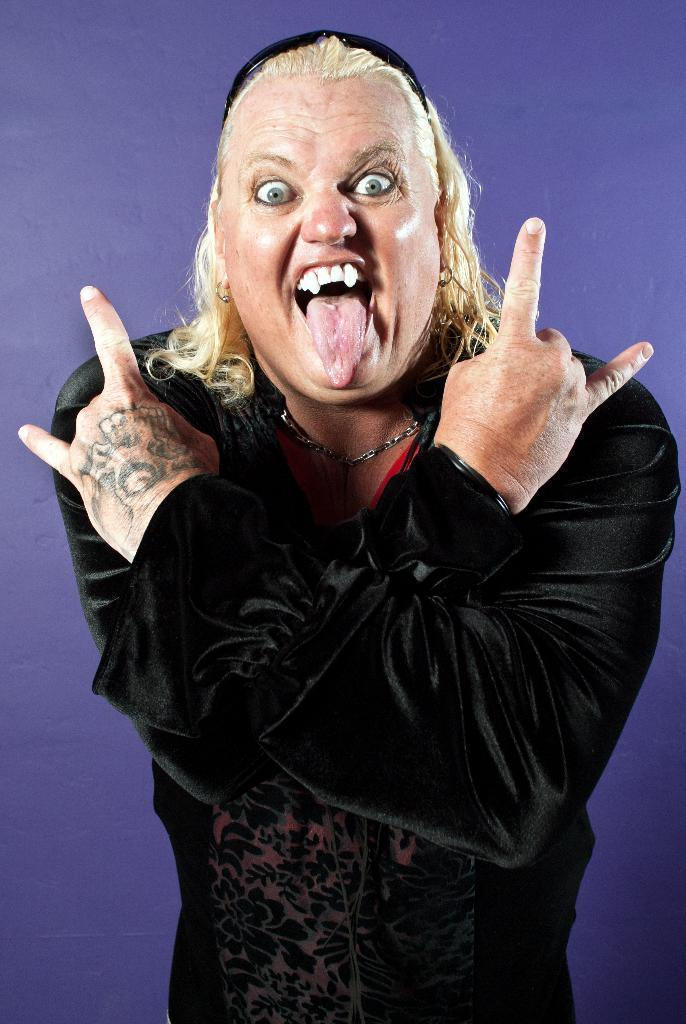What is the main subject of the image? The main subject of the image is a person. What is the person wearing in the image? The person is wearing a black dress. Can you describe any additional accessories the person is wearing? Yes, the person is wearing a band on their head. How many goldfish are swimming in the house in the image? There is no house or goldfish present in the image. 